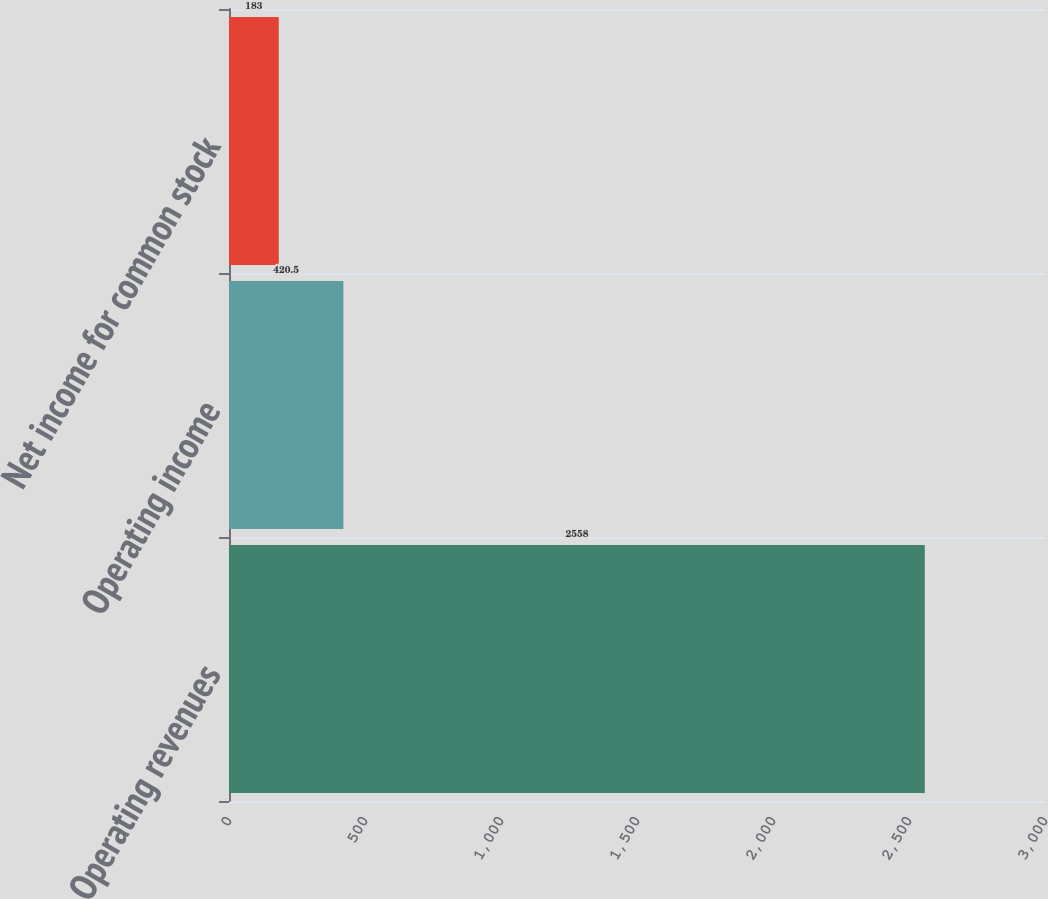<chart> <loc_0><loc_0><loc_500><loc_500><bar_chart><fcel>Operating revenues<fcel>Operating income<fcel>Net income for common stock<nl><fcel>2558<fcel>420.5<fcel>183<nl></chart> 